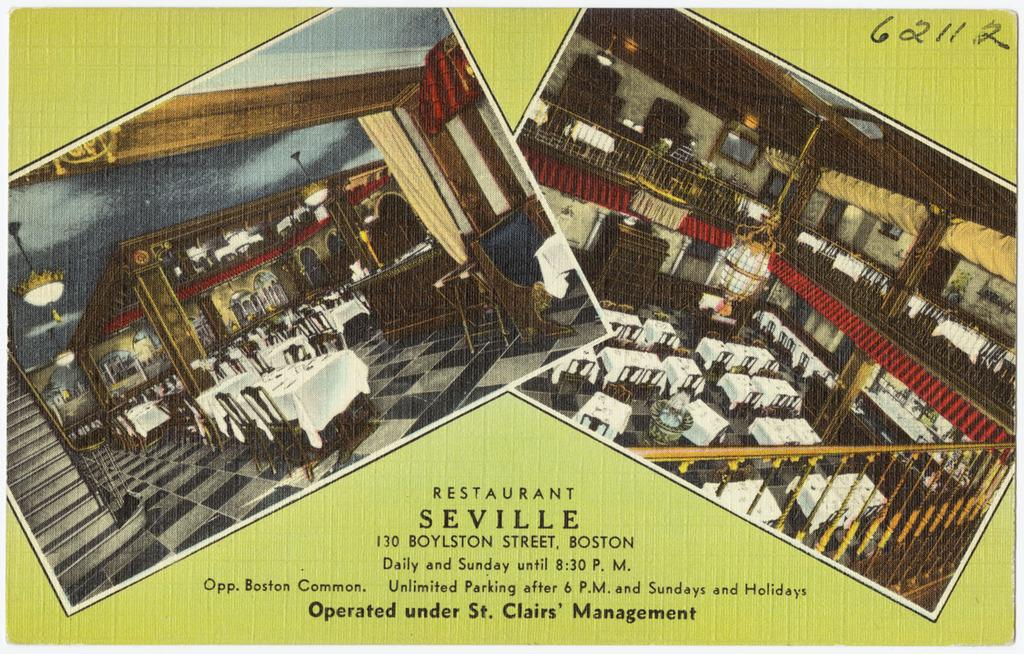<image>
Create a compact narrative representing the image presented. Restaurant Seville is located on Boylston Street in Boston. 